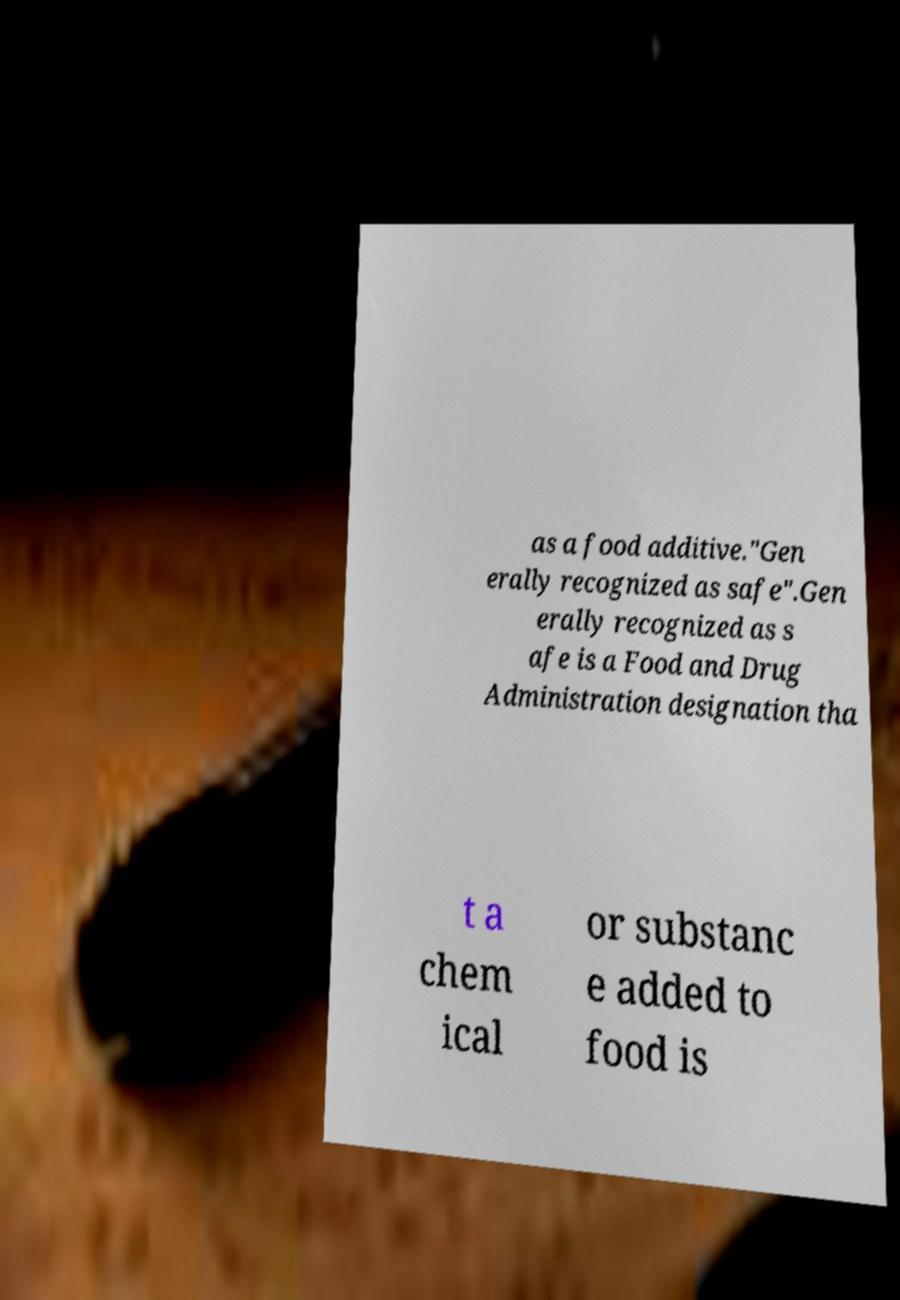For documentation purposes, I need the text within this image transcribed. Could you provide that? as a food additive."Gen erally recognized as safe".Gen erally recognized as s afe is a Food and Drug Administration designation tha t a chem ical or substanc e added to food is 